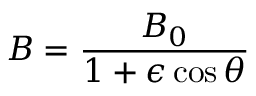<formula> <loc_0><loc_0><loc_500><loc_500>B = \frac { B _ { 0 } } { 1 + \epsilon \cos \theta }</formula> 